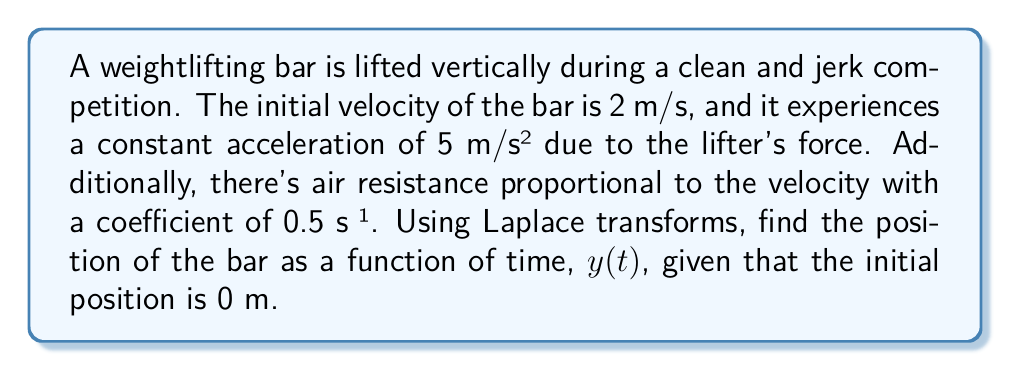Solve this math problem. Let's approach this problem step-by-step using Laplace transforms:

1) First, we set up the differential equation describing the motion:

   $$\frac{d^2y}{dt^2} + 0.5\frac{dy}{dt} = 5$$

   with initial conditions $y(0) = 0$ and $y'(0) = 2$.

2) Taking the Laplace transform of both sides:

   $$\mathcal{L}\{\frac{d^2y}{dt^2}\} + 0.5\mathcal{L}\{\frac{dy}{dt}\} = \mathcal{L}\{5\}$$

3) Using Laplace transform properties:

   $$s^2Y(s) - sy(0) - y'(0) + 0.5[sY(s) - y(0)] = \frac{5}{s}$$

4) Substituting the initial conditions:

   $$s^2Y(s) - 2 + 0.5sY(s) = \frac{5}{s}$$

5) Rearranging terms:

   $$Y(s)(s^2 + 0.5s) = \frac{5}{s} + 2$$

6) Solving for $Y(s)$:

   $$Y(s) = \frac{5/s + 2}{s^2 + 0.5s} = \frac{5 + 2s}{s(s^2 + 0.5s)}$$

7) Partial fraction decomposition:

   $$Y(s) = \frac{A}{s} + \frac{B}{s + 0.5}$$

   where $A = 20$ and $B = -16$

8) Taking the inverse Laplace transform:

   $$y(t) = 20 - 16e^{-0.5t}$$

This gives us the position of the bar as a function of time.
Answer: $y(t) = 20 - 16e^{-0.5t}$ meters 